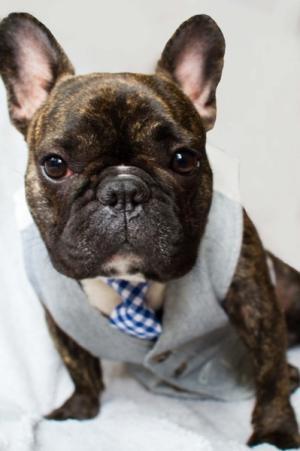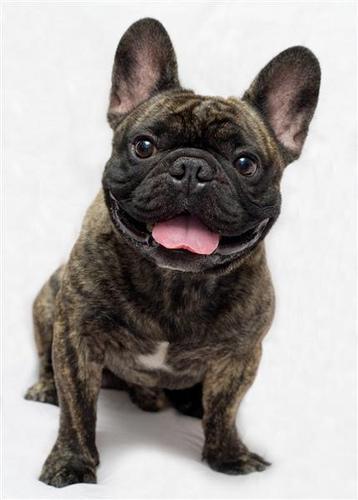The first image is the image on the left, the second image is the image on the right. Examine the images to the left and right. Is the description "An image shows one dog, which is wearing something made of printed fabric around its neck." accurate? Answer yes or no. Yes. The first image is the image on the left, the second image is the image on the right. For the images displayed, is the sentence "One dog has its mouth open and another dog has its mouth closed, and one of them is wearing a tie." factually correct? Answer yes or no. Yes. 